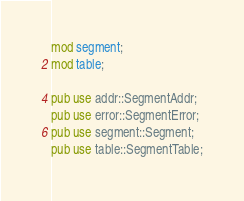Convert code to text. <code><loc_0><loc_0><loc_500><loc_500><_Rust_>mod segment;
mod table;

pub use addr::SegmentAddr;
pub use error::SegmentError;
pub use segment::Segment;
pub use table::SegmentTable;
</code> 